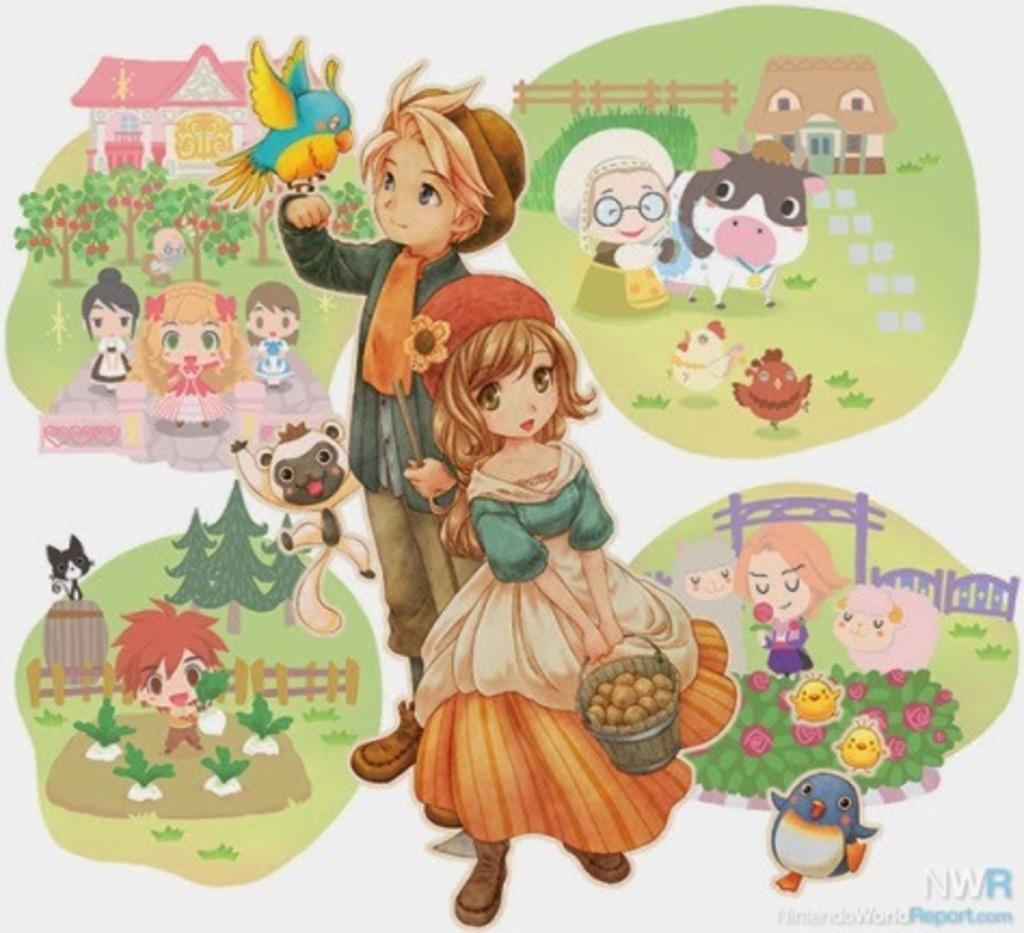Could you give a brief overview of what you see in this image? In this image we can see the cartoon pictures. 